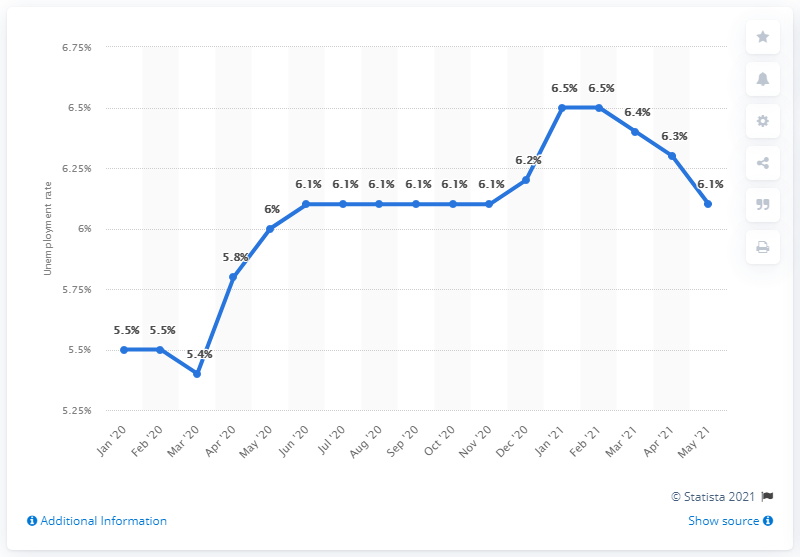List a handful of essential elements in this visual. According to data released in May 2021, the unemployment rate in Poland was 6.1%. 